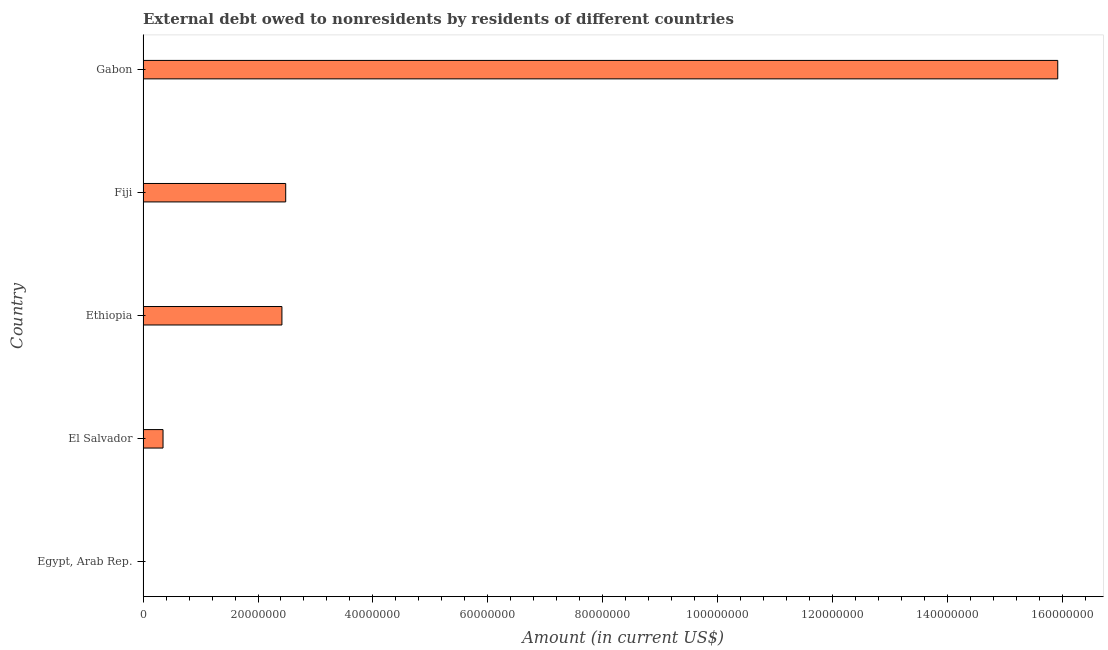Does the graph contain any zero values?
Keep it short and to the point. Yes. What is the title of the graph?
Give a very brief answer. External debt owed to nonresidents by residents of different countries. What is the label or title of the Y-axis?
Give a very brief answer. Country. What is the debt in Gabon?
Give a very brief answer. 1.59e+08. Across all countries, what is the maximum debt?
Ensure brevity in your answer.  1.59e+08. Across all countries, what is the minimum debt?
Your answer should be very brief. 0. In which country was the debt maximum?
Give a very brief answer. Gabon. What is the sum of the debt?
Your answer should be compact. 2.12e+08. What is the difference between the debt in Fiji and Gabon?
Give a very brief answer. -1.34e+08. What is the average debt per country?
Ensure brevity in your answer.  4.23e+07. What is the median debt?
Your answer should be very brief. 2.42e+07. What is the ratio of the debt in El Salvador to that in Ethiopia?
Your answer should be very brief. 0.14. Is the debt in Ethiopia less than that in Fiji?
Offer a terse response. Yes. Is the difference between the debt in Ethiopia and Fiji greater than the difference between any two countries?
Provide a succinct answer. No. What is the difference between the highest and the second highest debt?
Ensure brevity in your answer.  1.34e+08. What is the difference between the highest and the lowest debt?
Offer a very short reply. 1.59e+08. In how many countries, is the debt greater than the average debt taken over all countries?
Your answer should be very brief. 1. How many bars are there?
Make the answer very short. 4. Are all the bars in the graph horizontal?
Provide a short and direct response. Yes. Are the values on the major ticks of X-axis written in scientific E-notation?
Offer a very short reply. No. What is the Amount (in current US$) in El Salvador?
Offer a terse response. 3.48e+06. What is the Amount (in current US$) in Ethiopia?
Your answer should be compact. 2.42e+07. What is the Amount (in current US$) in Fiji?
Give a very brief answer. 2.48e+07. What is the Amount (in current US$) of Gabon?
Make the answer very short. 1.59e+08. What is the difference between the Amount (in current US$) in El Salvador and Ethiopia?
Ensure brevity in your answer.  -2.07e+07. What is the difference between the Amount (in current US$) in El Salvador and Fiji?
Your answer should be compact. -2.13e+07. What is the difference between the Amount (in current US$) in El Salvador and Gabon?
Offer a terse response. -1.56e+08. What is the difference between the Amount (in current US$) in Ethiopia and Fiji?
Keep it short and to the point. -6.56e+05. What is the difference between the Amount (in current US$) in Ethiopia and Gabon?
Offer a very short reply. -1.35e+08. What is the difference between the Amount (in current US$) in Fiji and Gabon?
Your answer should be very brief. -1.34e+08. What is the ratio of the Amount (in current US$) in El Salvador to that in Ethiopia?
Keep it short and to the point. 0.14. What is the ratio of the Amount (in current US$) in El Salvador to that in Fiji?
Give a very brief answer. 0.14. What is the ratio of the Amount (in current US$) in El Salvador to that in Gabon?
Keep it short and to the point. 0.02. What is the ratio of the Amount (in current US$) in Ethiopia to that in Gabon?
Make the answer very short. 0.15. What is the ratio of the Amount (in current US$) in Fiji to that in Gabon?
Your response must be concise. 0.16. 